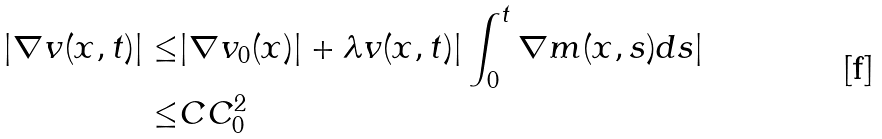Convert formula to latex. <formula><loc_0><loc_0><loc_500><loc_500>| \nabla v ( x , t ) | \leq & | \nabla v _ { 0 } ( x ) | + \lambda v ( x , t ) | \int _ { 0 } ^ { t } \nabla m ( x , s ) d s | \\ \leq & C C _ { 0 } ^ { 2 }</formula> 